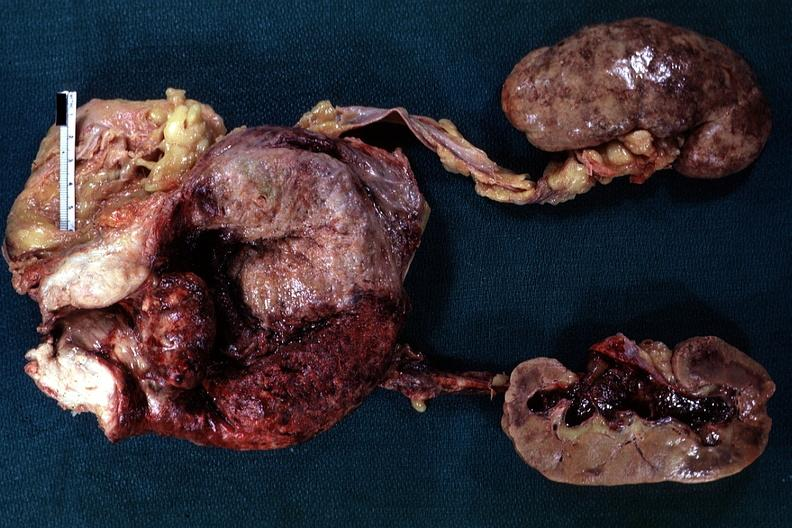what does this image show?
Answer the question using a single word or phrase. Large median bar type lesion with severe cystitis 